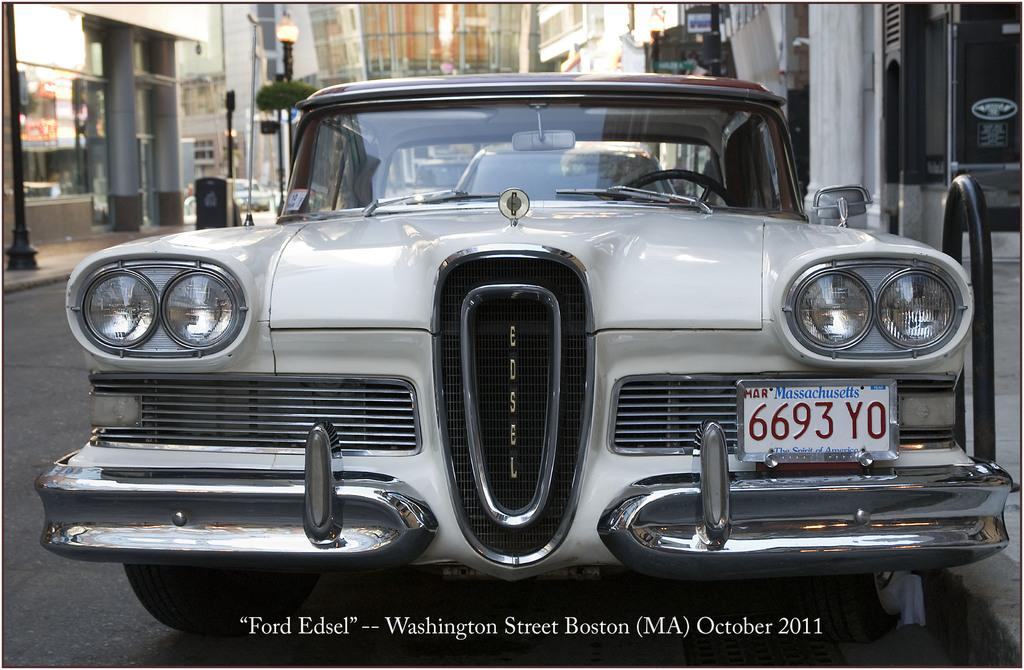<image>
Give a short and clear explanation of the subsequent image. In Massachusetts someone owns a Ford Edsel with a tag reading 6693 YO. 